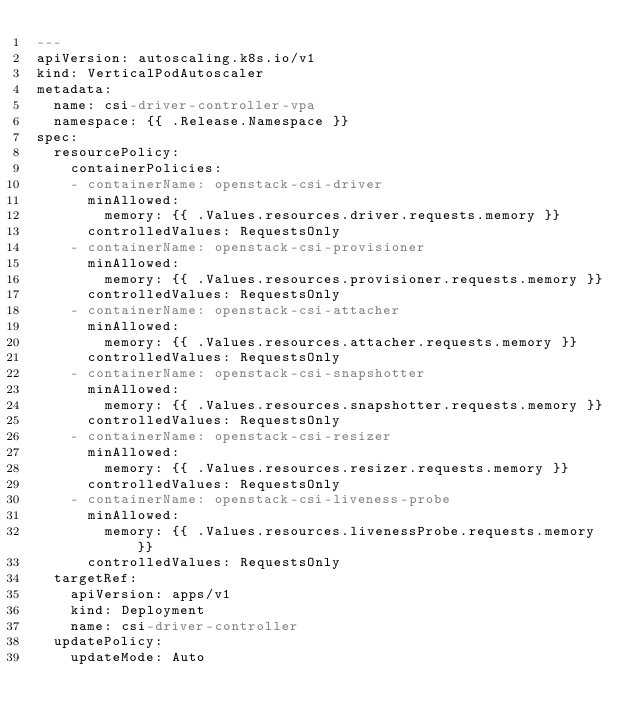<code> <loc_0><loc_0><loc_500><loc_500><_YAML_>---
apiVersion: autoscaling.k8s.io/v1
kind: VerticalPodAutoscaler
metadata:
  name: csi-driver-controller-vpa
  namespace: {{ .Release.Namespace }}
spec:
  resourcePolicy:
    containerPolicies:
    - containerName: openstack-csi-driver
      minAllowed:
        memory: {{ .Values.resources.driver.requests.memory }}
      controlledValues: RequestsOnly
    - containerName: openstack-csi-provisioner
      minAllowed:
        memory: {{ .Values.resources.provisioner.requests.memory }}
      controlledValues: RequestsOnly
    - containerName: openstack-csi-attacher
      minAllowed:
        memory: {{ .Values.resources.attacher.requests.memory }}
      controlledValues: RequestsOnly
    - containerName: openstack-csi-snapshotter
      minAllowed:
        memory: {{ .Values.resources.snapshotter.requests.memory }}
      controlledValues: RequestsOnly
    - containerName: openstack-csi-resizer
      minAllowed:
        memory: {{ .Values.resources.resizer.requests.memory }}
      controlledValues: RequestsOnly
    - containerName: openstack-csi-liveness-probe
      minAllowed:
        memory: {{ .Values.resources.livenessProbe.requests.memory }}
      controlledValues: RequestsOnly
  targetRef:
    apiVersion: apps/v1
    kind: Deployment
    name: csi-driver-controller
  updatePolicy:
    updateMode: Auto
</code> 